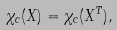<formula> <loc_0><loc_0><loc_500><loc_500>\chi _ { c } ( X ) = \chi _ { c } ( X ^ { T } ) ,</formula> 